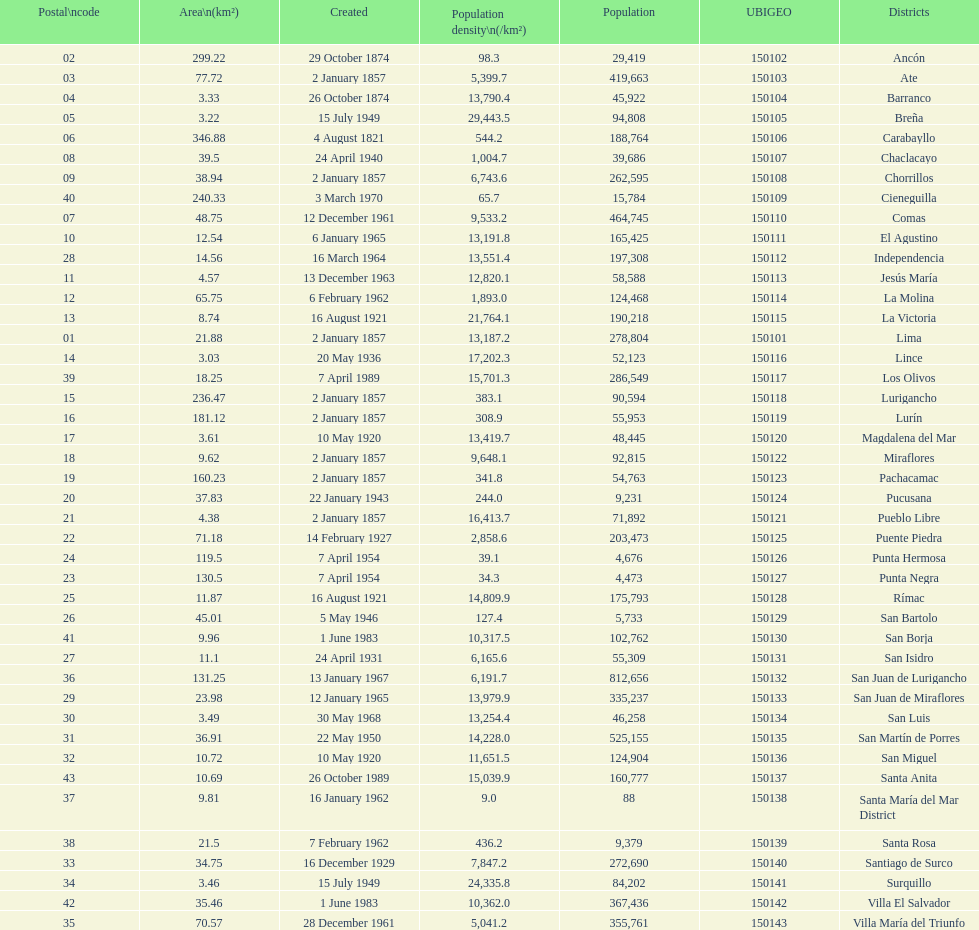Which district in this city has the greatest population? San Juan de Lurigancho. 